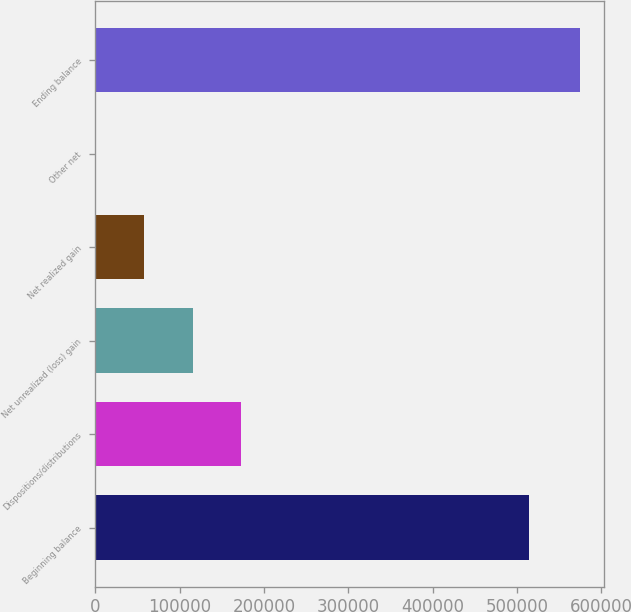<chart> <loc_0><loc_0><loc_500><loc_500><bar_chart><fcel>Beginning balance<fcel>Dispositions/distributions<fcel>Net unrealized (loss) gain<fcel>Net realized gain<fcel>Other net<fcel>Ending balance<nl><fcel>513973<fcel>172795<fcel>115371<fcel>57947.7<fcel>524<fcel>574761<nl></chart> 